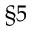Convert formula to latex. <formula><loc_0><loc_0><loc_500><loc_500>\S 5</formula> 